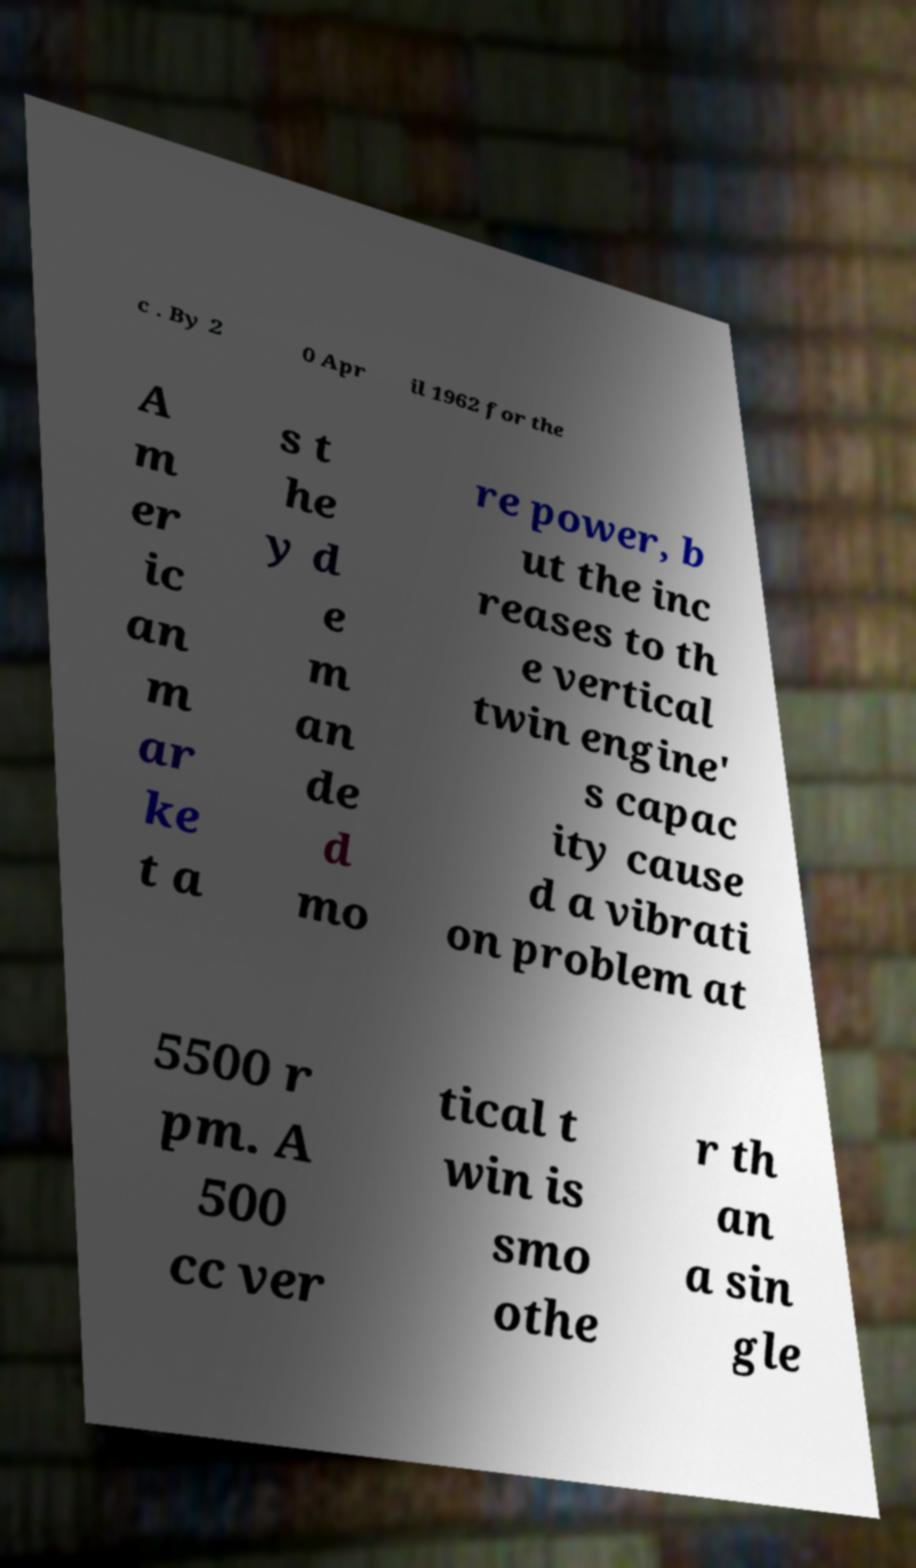Can you read and provide the text displayed in the image?This photo seems to have some interesting text. Can you extract and type it out for me? c . By 2 0 Apr il 1962 for the A m er ic an m ar ke t a s t he y d e m an de d mo re power, b ut the inc reases to th e vertical twin engine' s capac ity cause d a vibrati on problem at 5500 r pm. A 500 cc ver tical t win is smo othe r th an a sin gle 